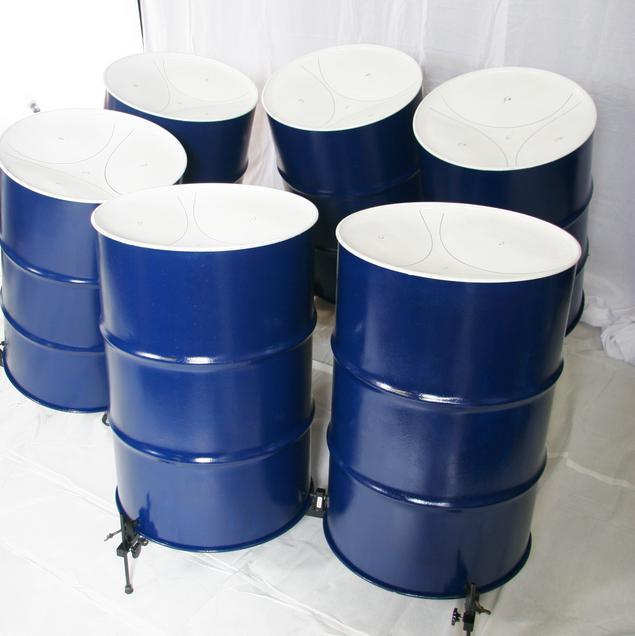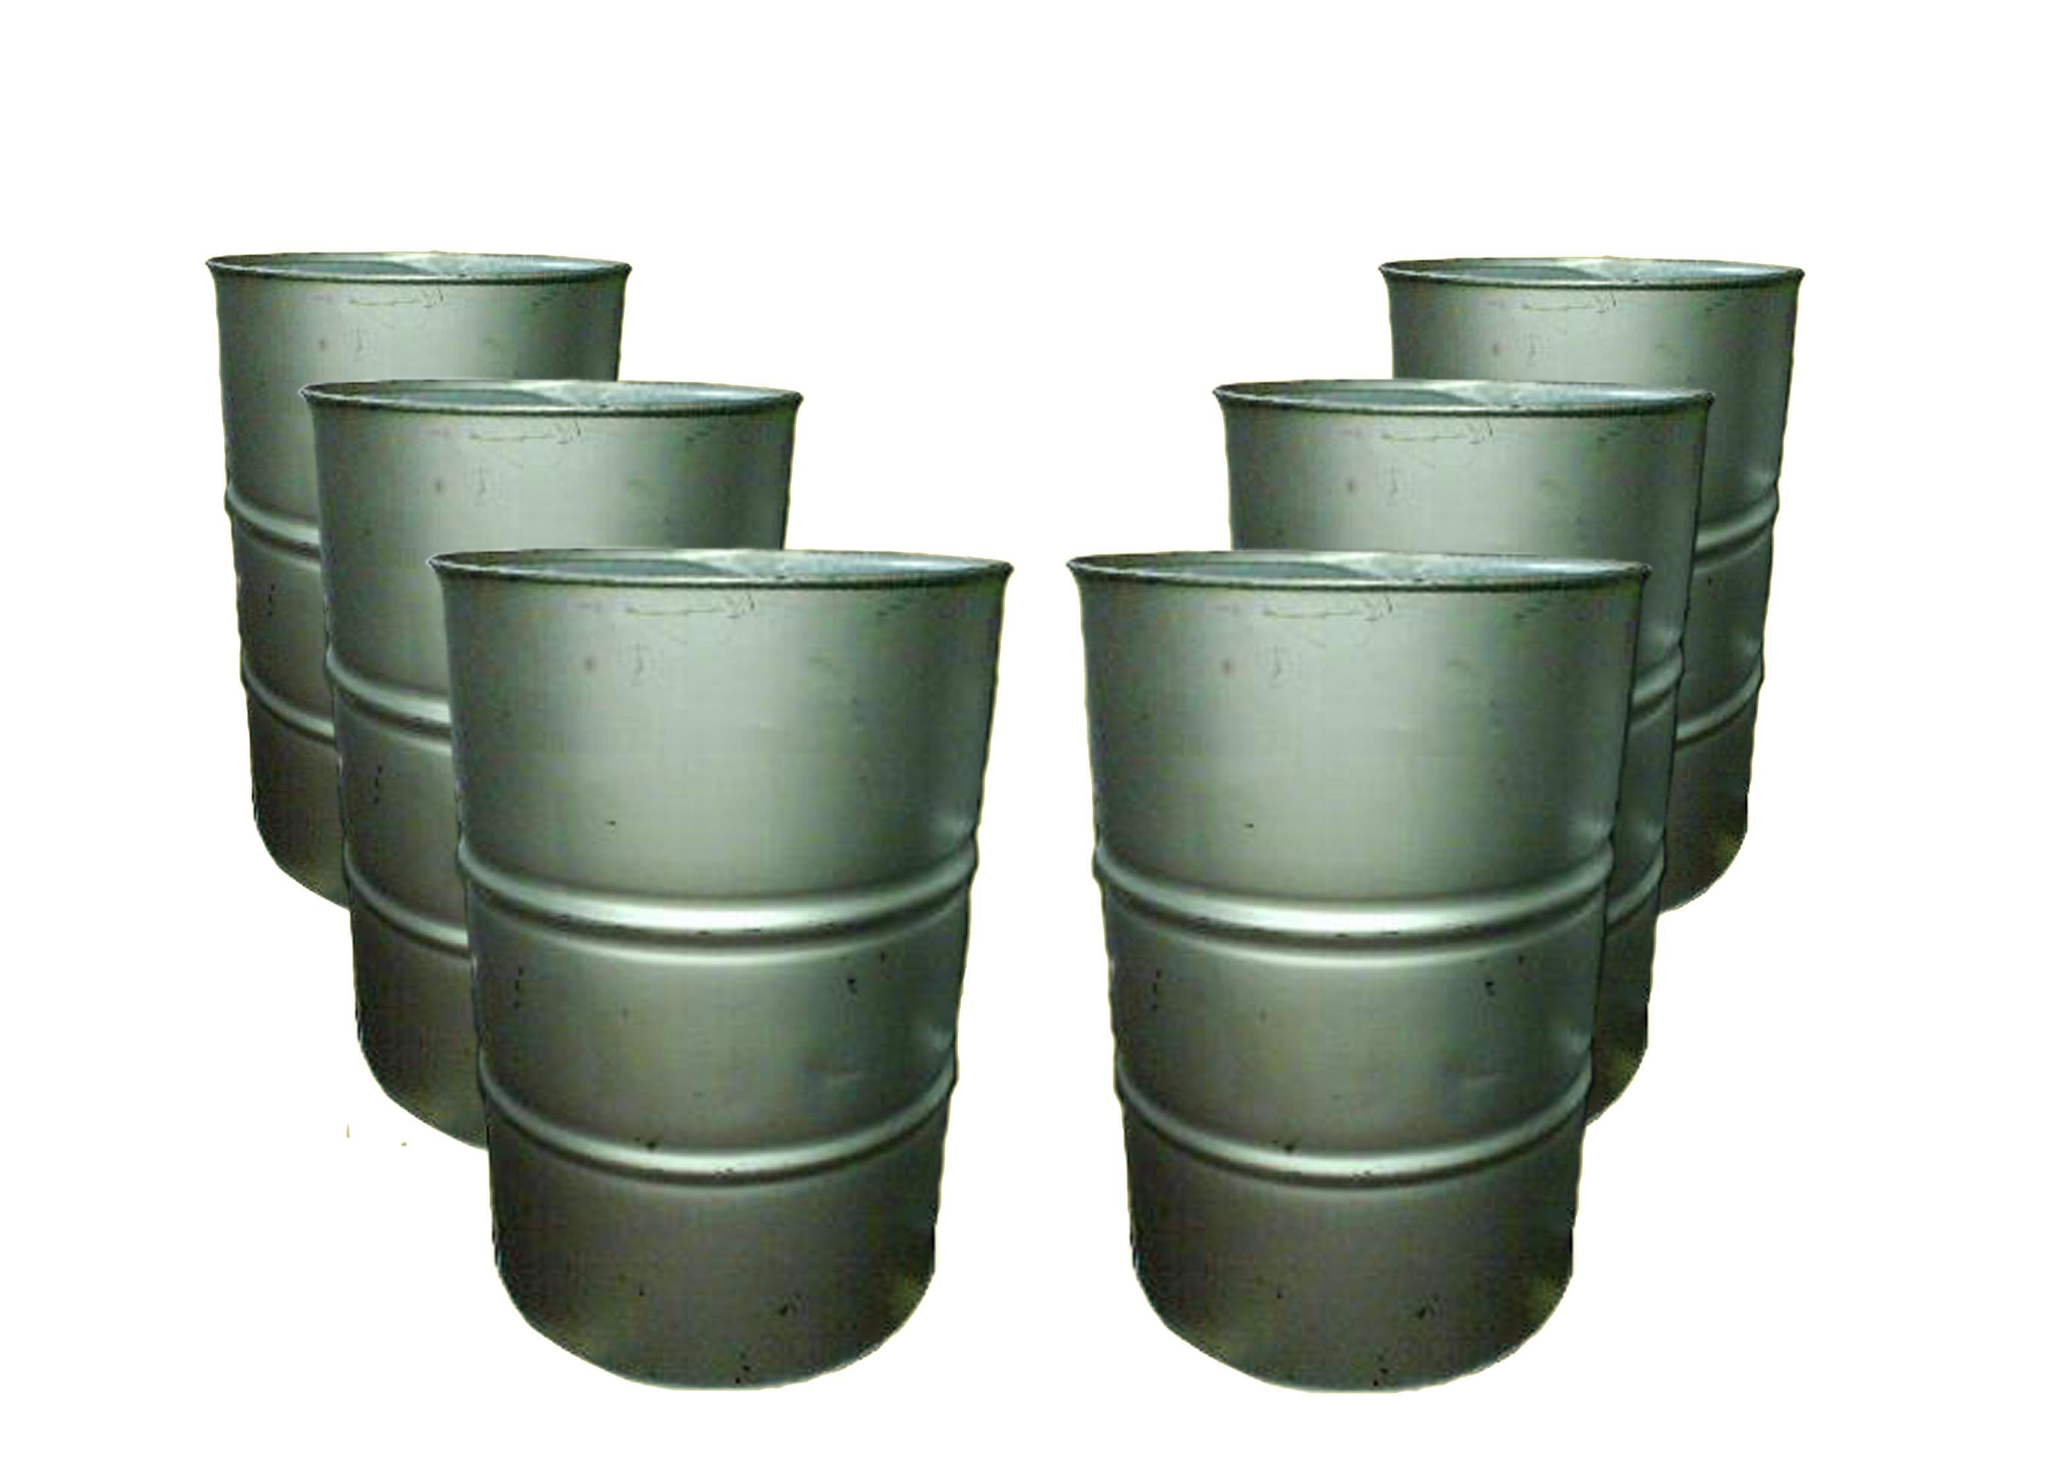The first image is the image on the left, the second image is the image on the right. Examine the images to the left and right. Is the description "The right image shows a pair of pink-tipped drumsticks resting on top of the middle of three upright black barrels, which stand in front of three non-upright black barrels." accurate? Answer yes or no. No. The first image is the image on the left, the second image is the image on the right. Examine the images to the left and right. Is the description "There is one image that includes fewer than six drums." accurate? Answer yes or no. No. 